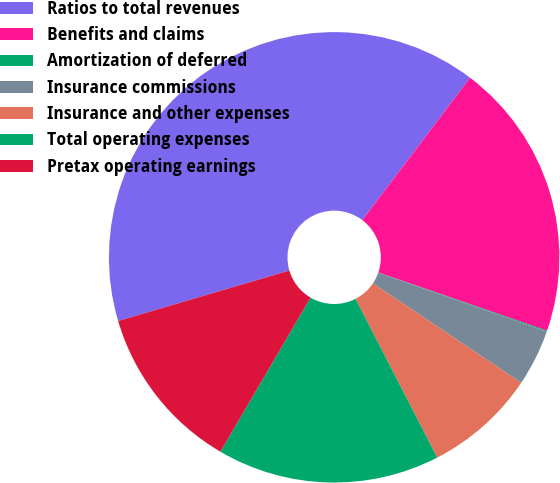Convert chart to OTSL. <chart><loc_0><loc_0><loc_500><loc_500><pie_chart><fcel>Ratios to total revenues<fcel>Benefits and claims<fcel>Amortization of deferred<fcel>Insurance commissions<fcel>Insurance and other expenses<fcel>Total operating expenses<fcel>Pretax operating earnings<nl><fcel>39.87%<fcel>19.97%<fcel>0.07%<fcel>4.05%<fcel>8.03%<fcel>15.99%<fcel>12.01%<nl></chart> 